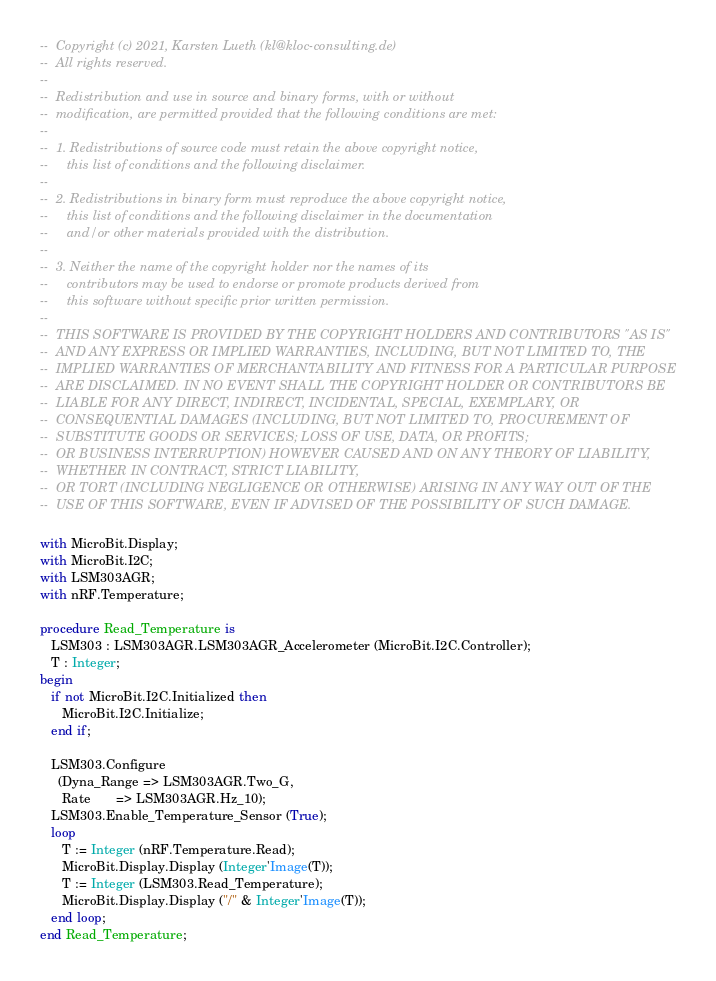Convert code to text. <code><loc_0><loc_0><loc_500><loc_500><_Ada_>--  Copyright (c) 2021, Karsten Lueth (kl@kloc-consulting.de)
--  All rights reserved.
--
--  Redistribution and use in source and binary forms, with or without
--  modification, are permitted provided that the following conditions are met:
--
--  1. Redistributions of source code must retain the above copyright notice,
--     this list of conditions and the following disclaimer.
--
--  2. Redistributions in binary form must reproduce the above copyright notice,
--     this list of conditions and the following disclaimer in the documentation
--     and/or other materials provided with the distribution.
--
--  3. Neither the name of the copyright holder nor the names of its
--     contributors may be used to endorse or promote products derived from
--     this software without specific prior written permission.
--
--  THIS SOFTWARE IS PROVIDED BY THE COPYRIGHT HOLDERS AND CONTRIBUTORS "AS IS"
--  AND ANY EXPRESS OR IMPLIED WARRANTIES, INCLUDING, BUT NOT LIMITED TO, THE
--  IMPLIED WARRANTIES OF MERCHANTABILITY AND FITNESS FOR A PARTICULAR PURPOSE
--  ARE DISCLAIMED. IN NO EVENT SHALL THE COPYRIGHT HOLDER OR CONTRIBUTORS BE
--  LIABLE FOR ANY DIRECT, INDIRECT, INCIDENTAL, SPECIAL, EXEMPLARY, OR
--  CONSEQUENTIAL DAMAGES (INCLUDING, BUT NOT LIMITED TO, PROCUREMENT OF
--  SUBSTITUTE GOODS OR SERVICES; LOSS OF USE, DATA, OR PROFITS;
--  OR BUSINESS INTERRUPTION) HOWEVER CAUSED AND ON ANY THEORY OF LIABILITY,
--  WHETHER IN CONTRACT, STRICT LIABILITY,
--  OR TORT (INCLUDING NEGLIGENCE OR OTHERWISE) ARISING IN ANY WAY OUT OF THE
--  USE OF THIS SOFTWARE, EVEN IF ADVISED OF THE POSSIBILITY OF SUCH DAMAGE.

with MicroBit.Display;
with MicroBit.I2C;
with LSM303AGR;
with nRF.Temperature;

procedure Read_Temperature is
   LSM303 : LSM303AGR.LSM303AGR_Accelerometer (MicroBit.I2C.Controller);
   T : Integer;
begin
   if not MicroBit.I2C.Initialized then
      MicroBit.I2C.Initialize;
   end if;

   LSM303.Configure
     (Dyna_Range => LSM303AGR.Two_G,
      Rate       => LSM303AGR.Hz_10);
   LSM303.Enable_Temperature_Sensor (True);
   loop
      T := Integer (nRF.Temperature.Read);
      MicroBit.Display.Display (Integer'Image(T));
      T := Integer (LSM303.Read_Temperature);
      MicroBit.Display.Display ("/" & Integer'Image(T));
   end loop;
end Read_Temperature;
</code> 